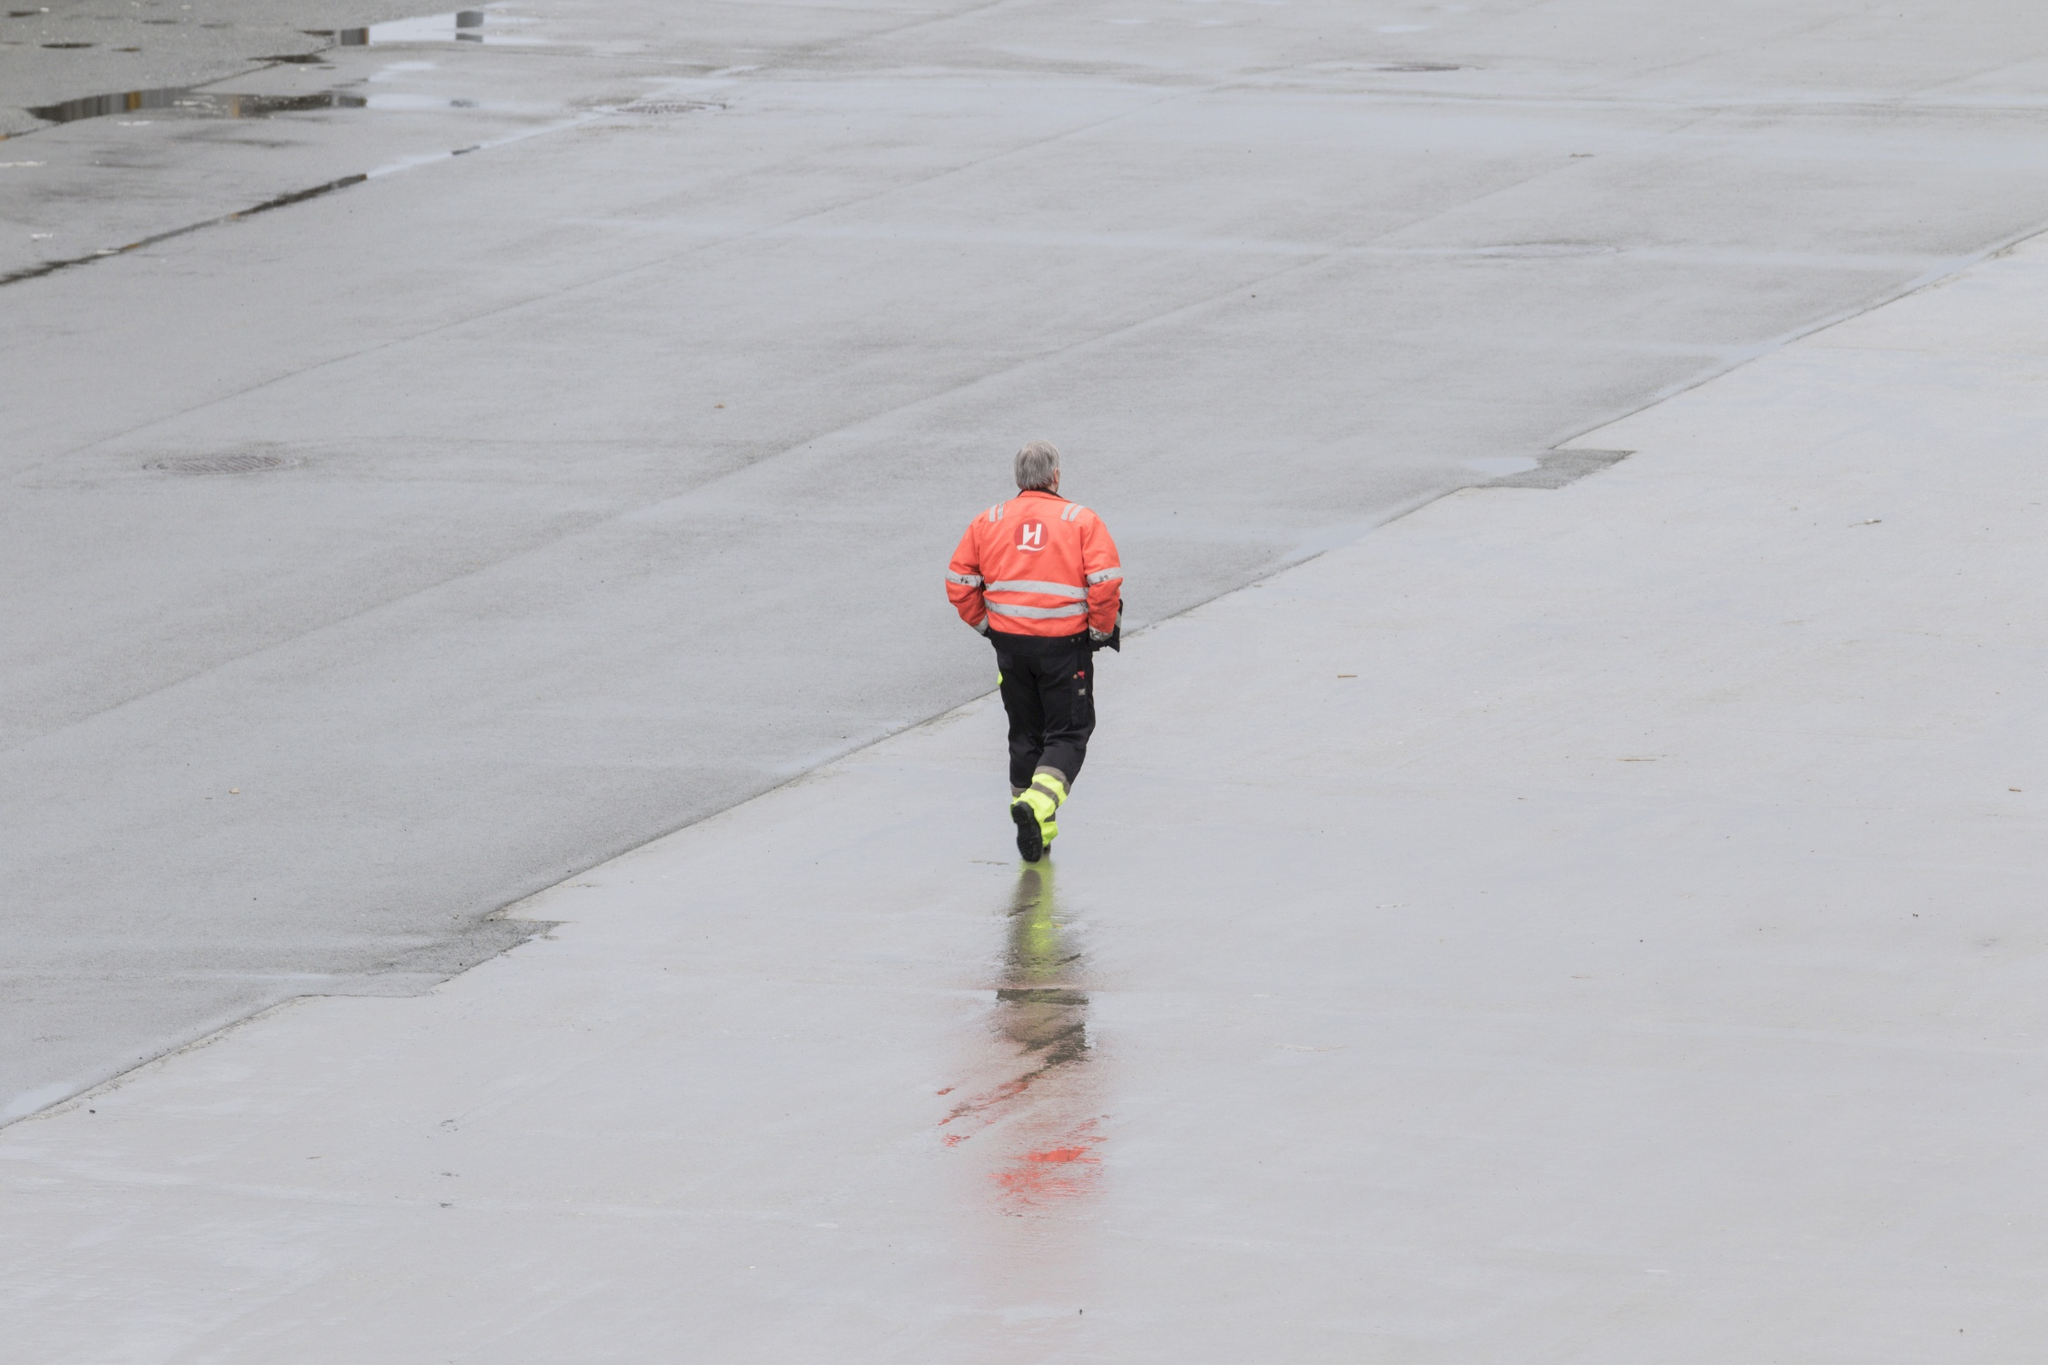What do you think is going on in this snapshot? The image depicts an individual in high-visibility clothing, denoted by an orange vest and reflective stripes. The person is walking on a large expanse of concrete, moving away from the camera's viewpoint. A distinctive detail is the presence of a vivid, red streak on the ground which the person appears to be following or inspecting. It's unclear what the substance is or the context of the situation. The scene could indicate an investigative action following an accident or incident, or perhaps maintenance work where the red substance needs to be addressed. Noteworthy is the solitary nature of the task, and the overcast sky that gives the scene a somber tone, enhancing the sense of urgency or concern associated with the person's activity. 